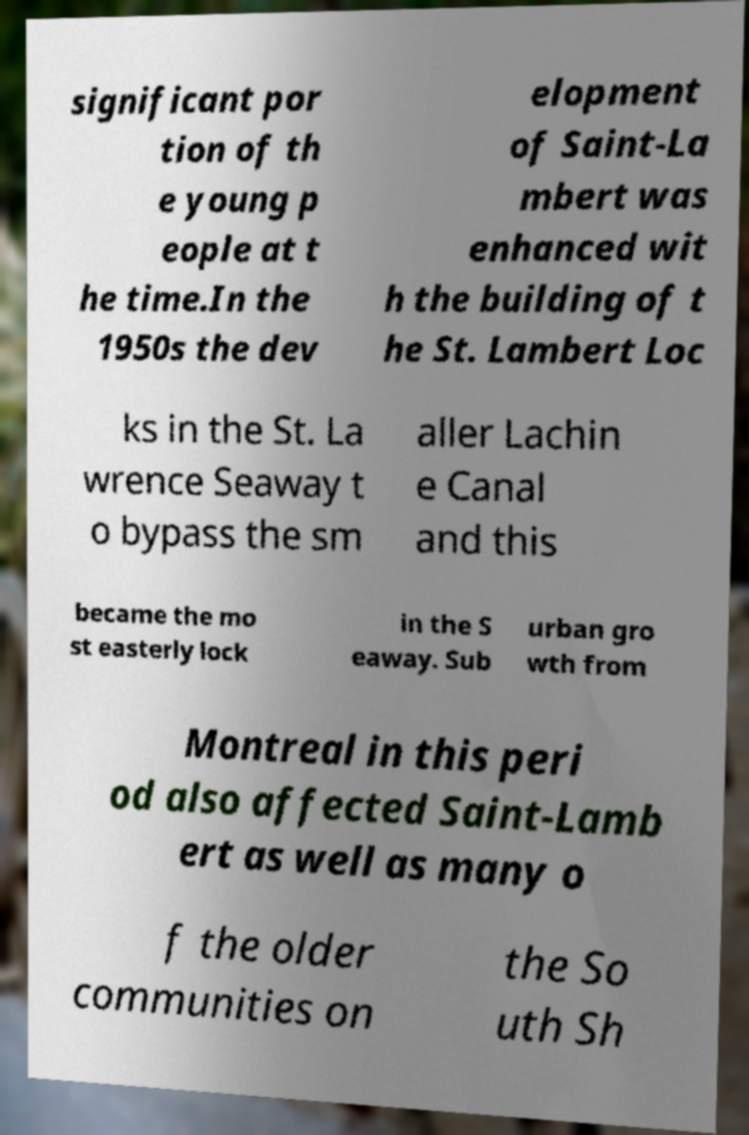Please identify and transcribe the text found in this image. significant por tion of th e young p eople at t he time.In the 1950s the dev elopment of Saint-La mbert was enhanced wit h the building of t he St. Lambert Loc ks in the St. La wrence Seaway t o bypass the sm aller Lachin e Canal and this became the mo st easterly lock in the S eaway. Sub urban gro wth from Montreal in this peri od also affected Saint-Lamb ert as well as many o f the older communities on the So uth Sh 